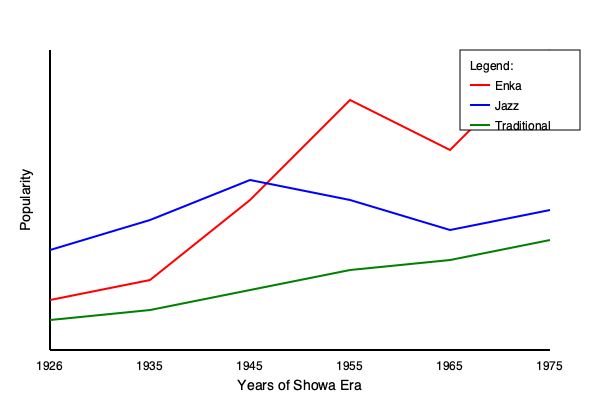Based on the line graph showing popularity trends of different music genres during the Showa era (1926-1989), which genre experienced the most significant rise in popularity between 1945 and 1955? To determine which genre experienced the most significant rise in popularity between 1945 and 1955, we need to analyze the graph step-by-step:

1. Identify the time period:
   - 1945 corresponds to the midpoint of the x-axis
   - 1955 corresponds to the point just right of the midpoint

2. Examine each genre's trend line:
   a) Enka (red line):
      - In 1945: approximately at popularity level 200
      - In 1955: approximately at popularity level 100
      - Shows a significant increase in popularity

   b) Jazz (blue line):
      - In 1945: approximately at popularity level 180
      - In 1955: approximately at popularity level 200
      - Shows a slight increase in popularity

   c) Traditional (green line):
      - In 1945: approximately at popularity level 290
      - In 1955: approximately at popularity level 270
      - Shows a slight decrease in popularity

3. Compare the changes:
   - Enka: Increased by about 100 points
   - Jazz: Increased by about 20 points
   - Traditional: Decreased by about 20 points

4. Conclusion:
   Enka experienced the most significant rise in popularity between 1945 and 1955, with the steepest upward slope and largest increase in popularity points.
Answer: Enka 